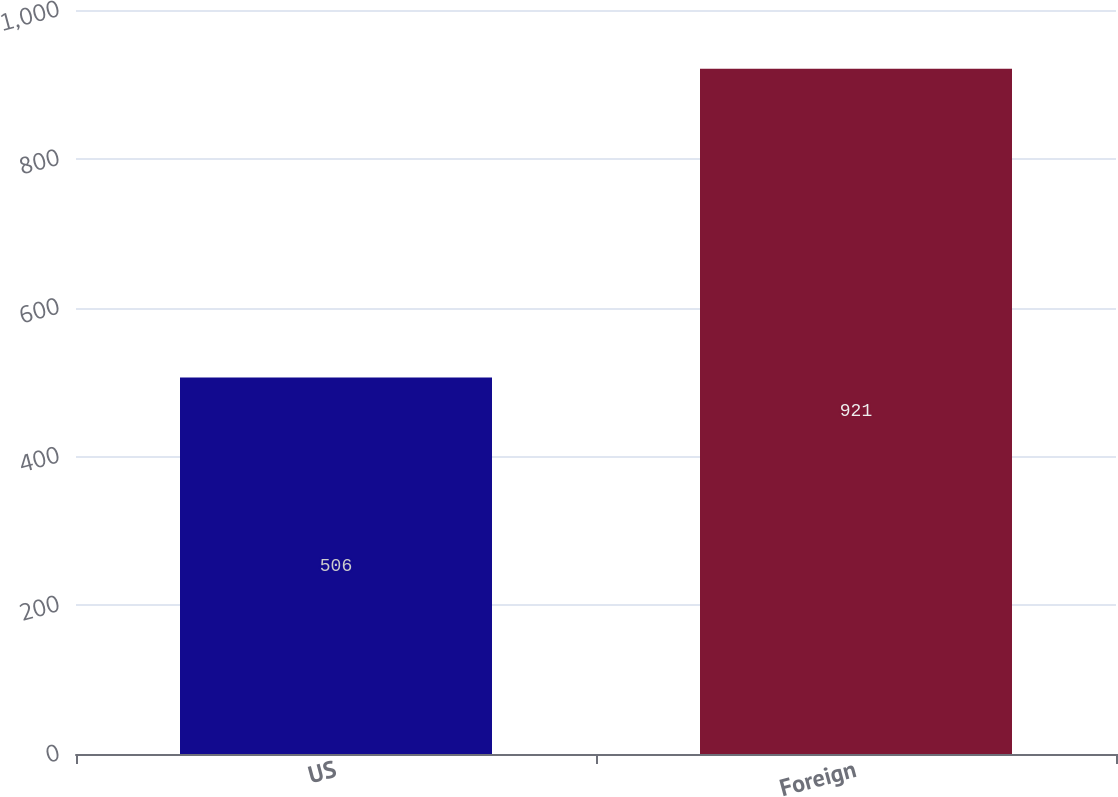Convert chart to OTSL. <chart><loc_0><loc_0><loc_500><loc_500><bar_chart><fcel>US<fcel>Foreign<nl><fcel>506<fcel>921<nl></chart> 